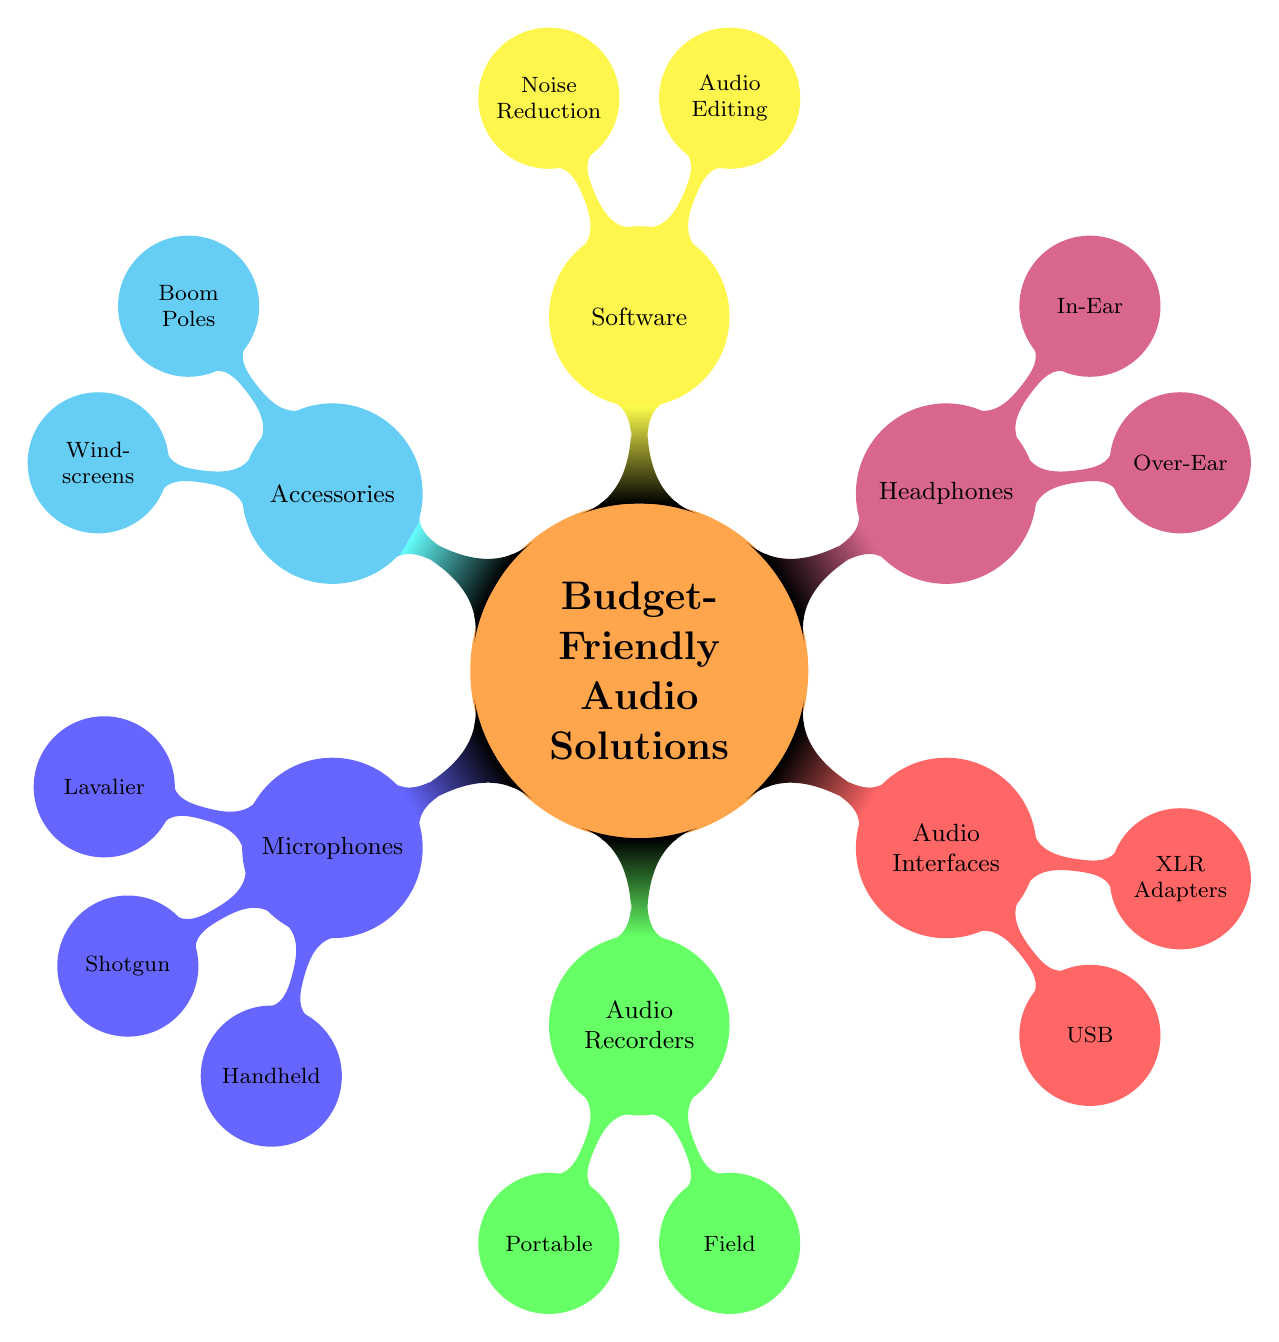What are the two main categories under Microphones? The section "Microphones" contains three child nodes: "Lavalier", "Shotgun", and "Handheld". The question specifically asks for the main categories, which are first and foremost "Lavalier" and "Shotgun".
Answer: Lavalier, Shotgun How many types of Audio Recorders are listed? The "Audio Recorders" category has two sub-nodes: "Portable" and "Field". Therefore, there are a total of two types listed under this node.
Answer: 2 What is a specific example of a Handheld Microphone? Under the "Handheld Microphones" node, there are two specific examples provided: "Shure SM58" and "Behringer Ultravoice XM8500". A specific example of a Handheld Microphone is "Shure SM58".
Answer: Shure SM58 Which node represents the accessories available for sound recording? The node labeled "Accessories" includes two sub-nodes: "Boom Poles" and "Windscreens". This is the designated section in the mind map for various accessories available for sound recording.
Answer: Accessories How many options are provided under Software? The "Software" node has two categories: "Audio Editing" and "Noise Reduction", which each contain two options. Thus, in total, there are four options provided under Software.
Answer: 4 Which type of headphones is mentioned as Over-Ear? The "Headphones" category features two nodes: "Over-Ear" and "In-Ear". One specified example under the "Over-Ear" node is "Sony MDR-7506", which is an Over-Ear headphone.
Answer: Sony MDR-7506 What is the relationship between Boom Poles and Accessories? "Boom Poles" is a child node under the "Accessories" parent node. This signifies that Boom Poles are one type of accessory that can be utilized in film production for sound recording.
Answer: Boom Poles Name a model of the USB Interface mentioned in the diagram. Within the "Audio Interfaces" category, under "USB", a specific model listed is "Focusrite Scarlett 2i2".
Answer: Focusrite Scarlett 2i2 